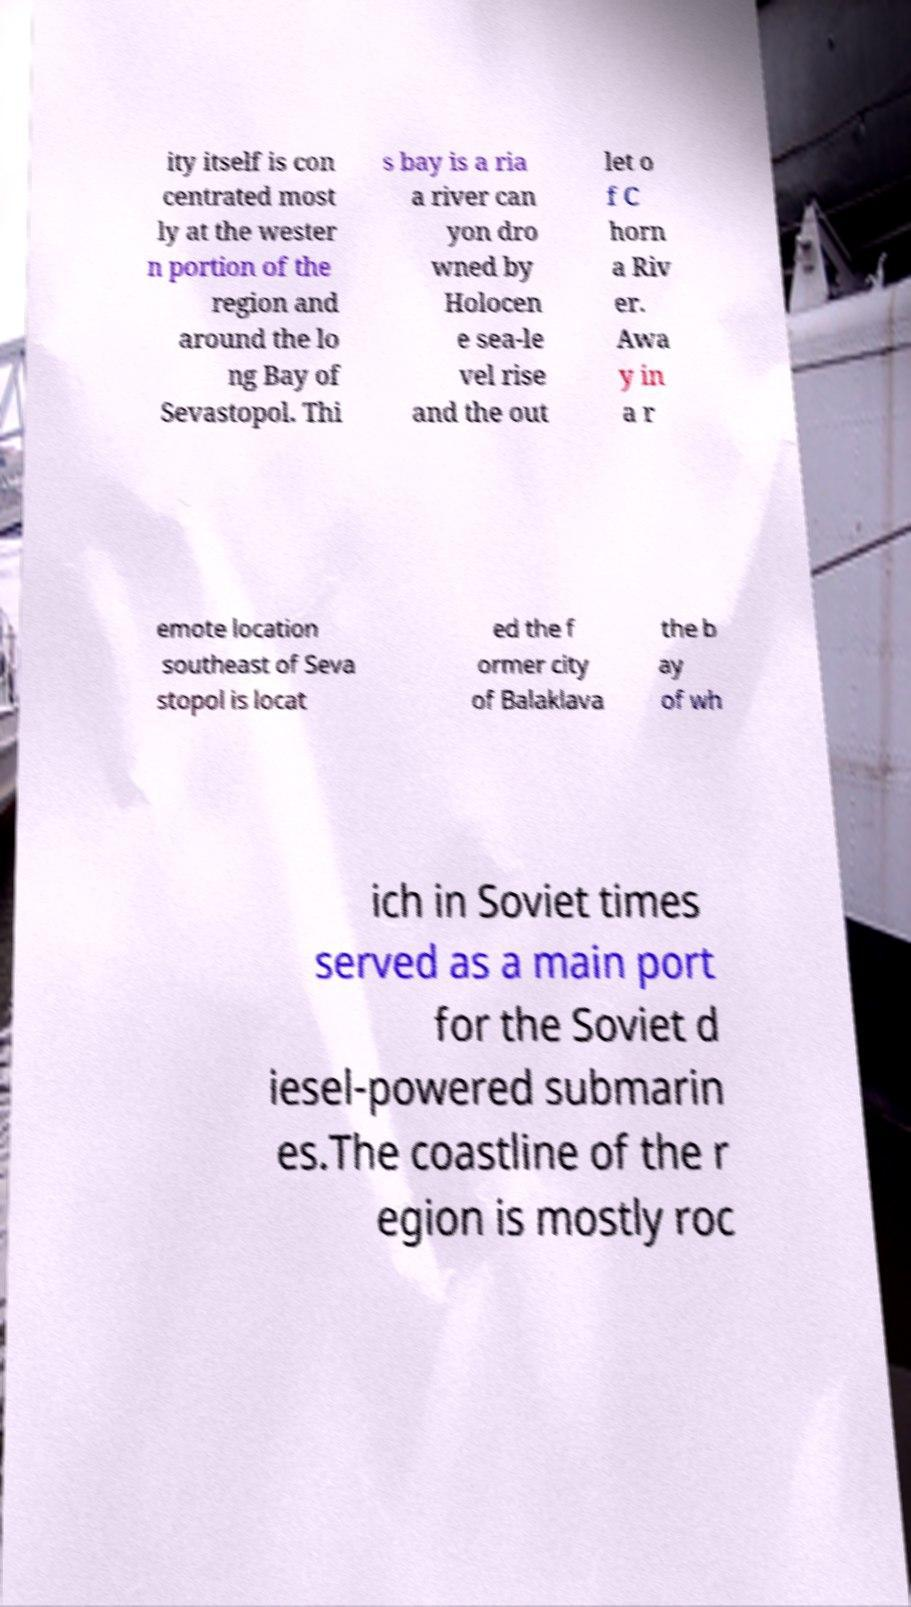Please identify and transcribe the text found in this image. ity itself is con centrated most ly at the wester n portion of the region and around the lo ng Bay of Sevastopol. Thi s bay is a ria a river can yon dro wned by Holocen e sea-le vel rise and the out let o f C horn a Riv er. Awa y in a r emote location southeast of Seva stopol is locat ed the f ormer city of Balaklava the b ay of wh ich in Soviet times served as a main port for the Soviet d iesel-powered submarin es.The coastline of the r egion is mostly roc 